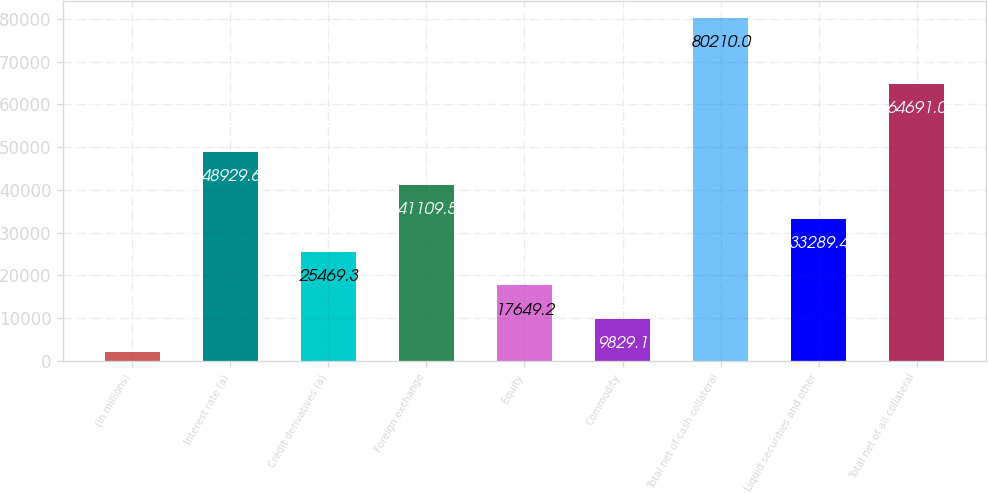Convert chart. <chart><loc_0><loc_0><loc_500><loc_500><bar_chart><fcel>(in millions)<fcel>Interest rate (a)<fcel>Credit derivatives (a)<fcel>Foreign exchange<fcel>Equity<fcel>Commodity<fcel>Total net of cash collateral<fcel>Liquid securities and other<fcel>Total net of all collateral<nl><fcel>2009<fcel>48929.6<fcel>25469.3<fcel>41109.5<fcel>17649.2<fcel>9829.1<fcel>80210<fcel>33289.4<fcel>64691<nl></chart> 